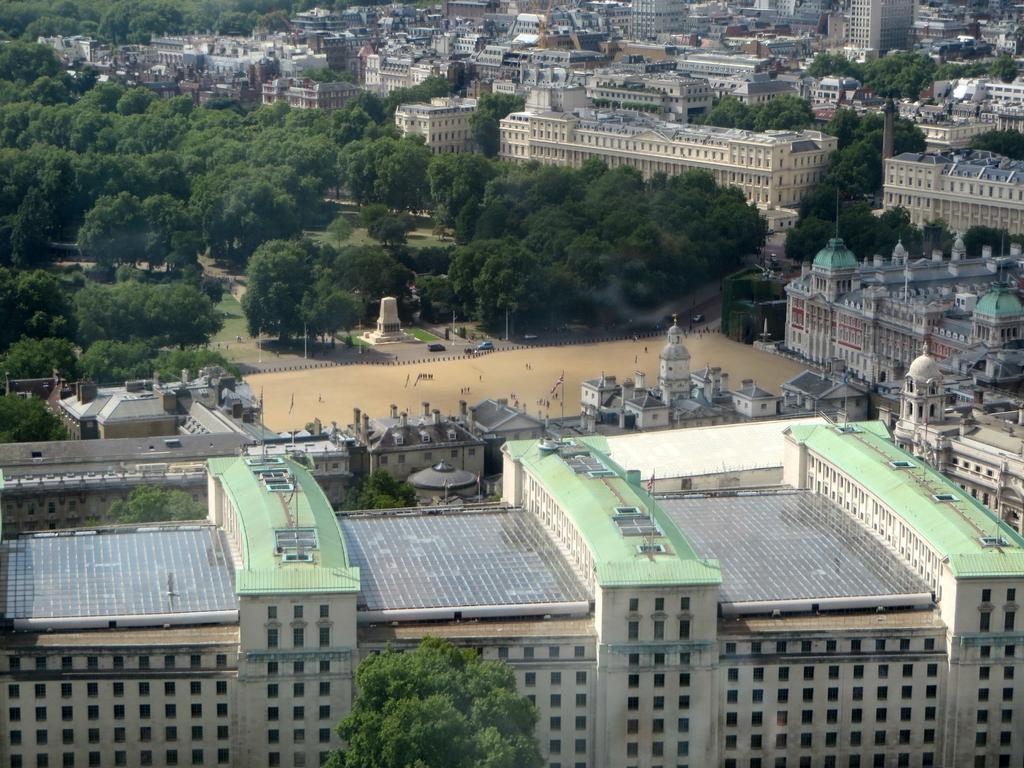Describe this image in one or two sentences. In this image we can see the buildings and trees. Here we can see the flag poles on the top of the building. Here we can see the vehicles on the road. 